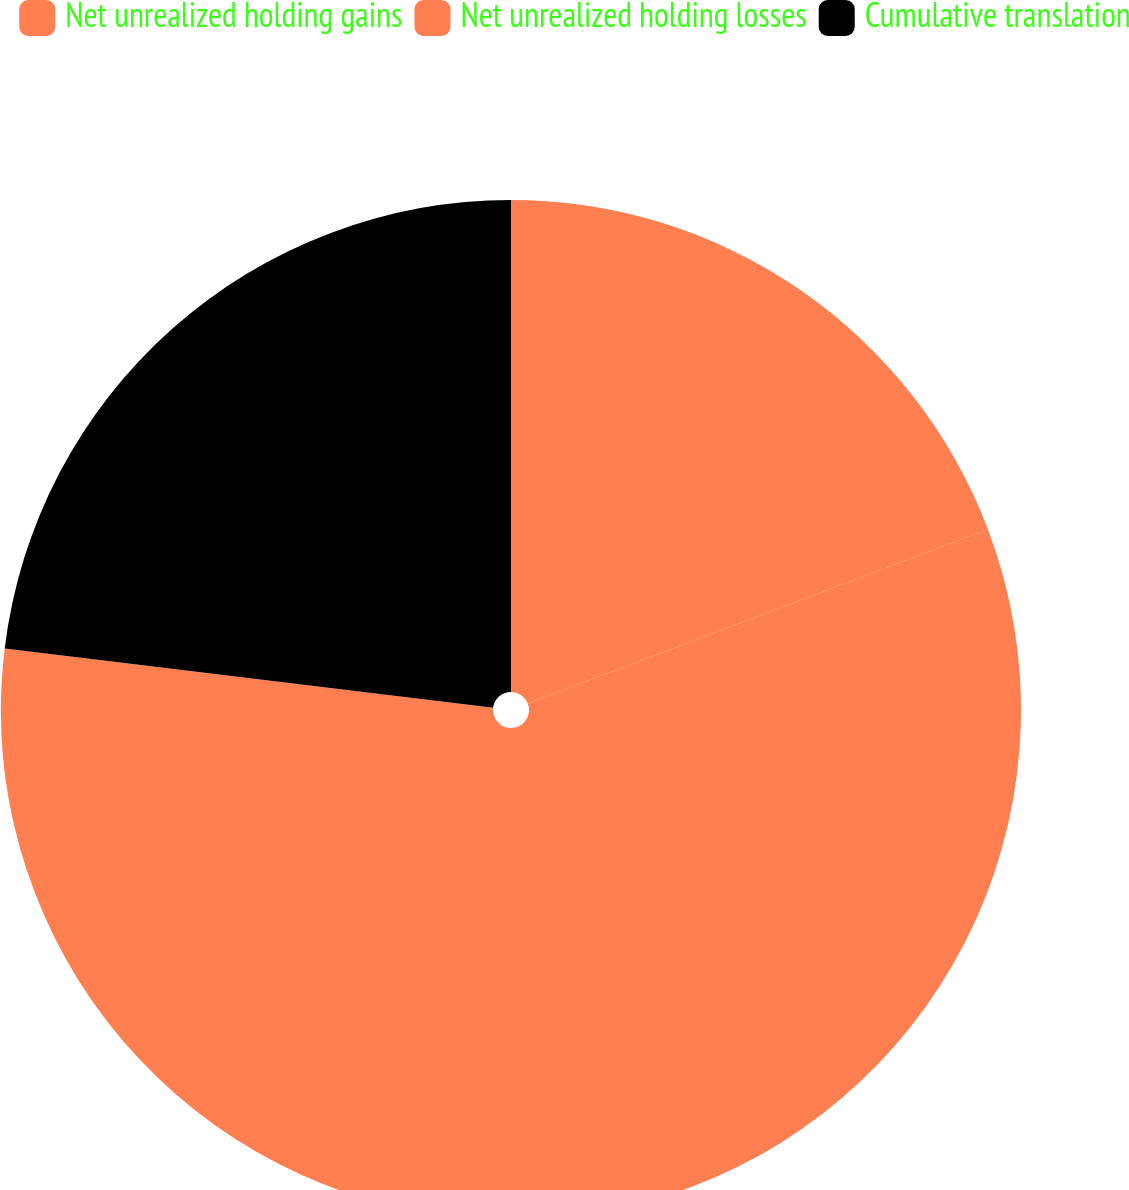Convert chart to OTSL. <chart><loc_0><loc_0><loc_500><loc_500><pie_chart><fcel>Net unrealized holding gains<fcel>Net unrealized holding losses<fcel>Cumulative translation<nl><fcel>19.23%<fcel>57.69%<fcel>23.08%<nl></chart> 